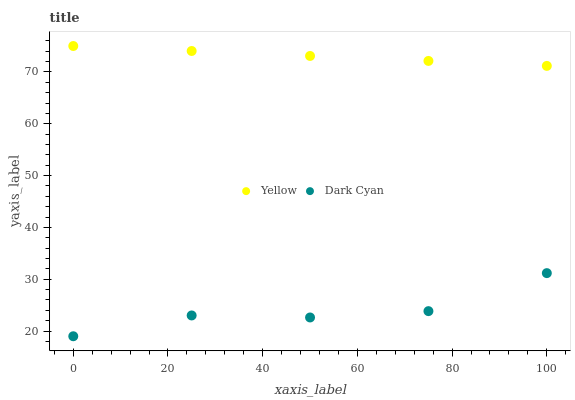Does Dark Cyan have the minimum area under the curve?
Answer yes or no. Yes. Does Yellow have the maximum area under the curve?
Answer yes or no. Yes. Does Yellow have the minimum area under the curve?
Answer yes or no. No. Is Yellow the smoothest?
Answer yes or no. Yes. Is Dark Cyan the roughest?
Answer yes or no. Yes. Is Yellow the roughest?
Answer yes or no. No. Does Dark Cyan have the lowest value?
Answer yes or no. Yes. Does Yellow have the lowest value?
Answer yes or no. No. Does Yellow have the highest value?
Answer yes or no. Yes. Is Dark Cyan less than Yellow?
Answer yes or no. Yes. Is Yellow greater than Dark Cyan?
Answer yes or no. Yes. Does Dark Cyan intersect Yellow?
Answer yes or no. No. 